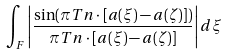Convert formula to latex. <formula><loc_0><loc_0><loc_500><loc_500>\int _ { F } \left | \frac { \sin ( \pi T n \cdot [ a ( \xi ) - a ( \zeta ) ] ) } { \pi T n \cdot [ a ( \xi ) - a ( \zeta ) ] } \right | d \xi</formula> 